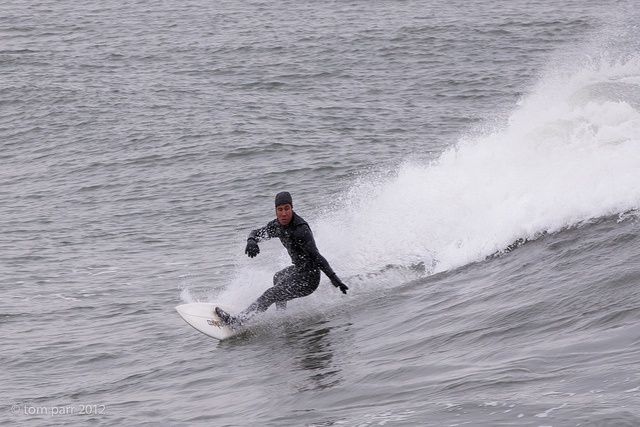Describe the objects in this image and their specific colors. I can see people in darkgray, black, gray, and lightgray tones and surfboard in darkgray, lightgray, and gray tones in this image. 